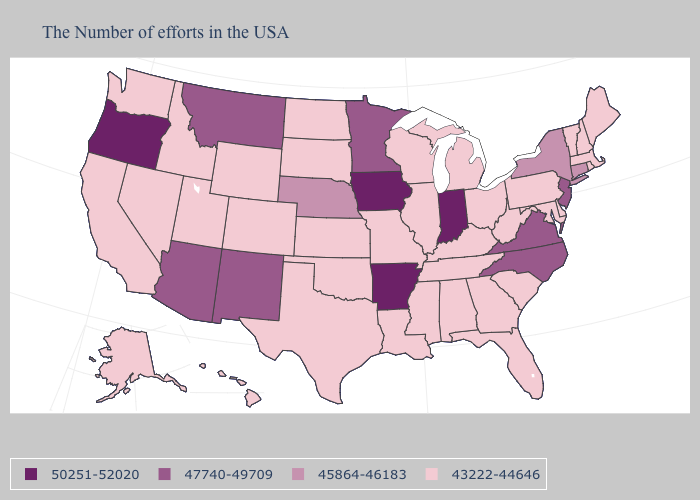Does the map have missing data?
Answer briefly. No. What is the value of Minnesota?
Short answer required. 47740-49709. Does the first symbol in the legend represent the smallest category?
Short answer required. No. Which states have the lowest value in the USA?
Write a very short answer. Maine, Massachusetts, Rhode Island, New Hampshire, Vermont, Delaware, Maryland, Pennsylvania, South Carolina, West Virginia, Ohio, Florida, Georgia, Michigan, Kentucky, Alabama, Tennessee, Wisconsin, Illinois, Mississippi, Louisiana, Missouri, Kansas, Oklahoma, Texas, South Dakota, North Dakota, Wyoming, Colorado, Utah, Idaho, Nevada, California, Washington, Alaska, Hawaii. Among the states that border Delaware , which have the lowest value?
Answer briefly. Maryland, Pennsylvania. What is the lowest value in the MidWest?
Short answer required. 43222-44646. Does New Mexico have the lowest value in the USA?
Short answer required. No. Does South Dakota have a lower value than Ohio?
Short answer required. No. Name the states that have a value in the range 43222-44646?
Quick response, please. Maine, Massachusetts, Rhode Island, New Hampshire, Vermont, Delaware, Maryland, Pennsylvania, South Carolina, West Virginia, Ohio, Florida, Georgia, Michigan, Kentucky, Alabama, Tennessee, Wisconsin, Illinois, Mississippi, Louisiana, Missouri, Kansas, Oklahoma, Texas, South Dakota, North Dakota, Wyoming, Colorado, Utah, Idaho, Nevada, California, Washington, Alaska, Hawaii. What is the value of Rhode Island?
Answer briefly. 43222-44646. What is the value of Hawaii?
Quick response, please. 43222-44646. Does New Mexico have a lower value than Oregon?
Concise answer only. Yes. What is the lowest value in states that border Arkansas?
Write a very short answer. 43222-44646. What is the lowest value in the USA?
Be succinct. 43222-44646. 